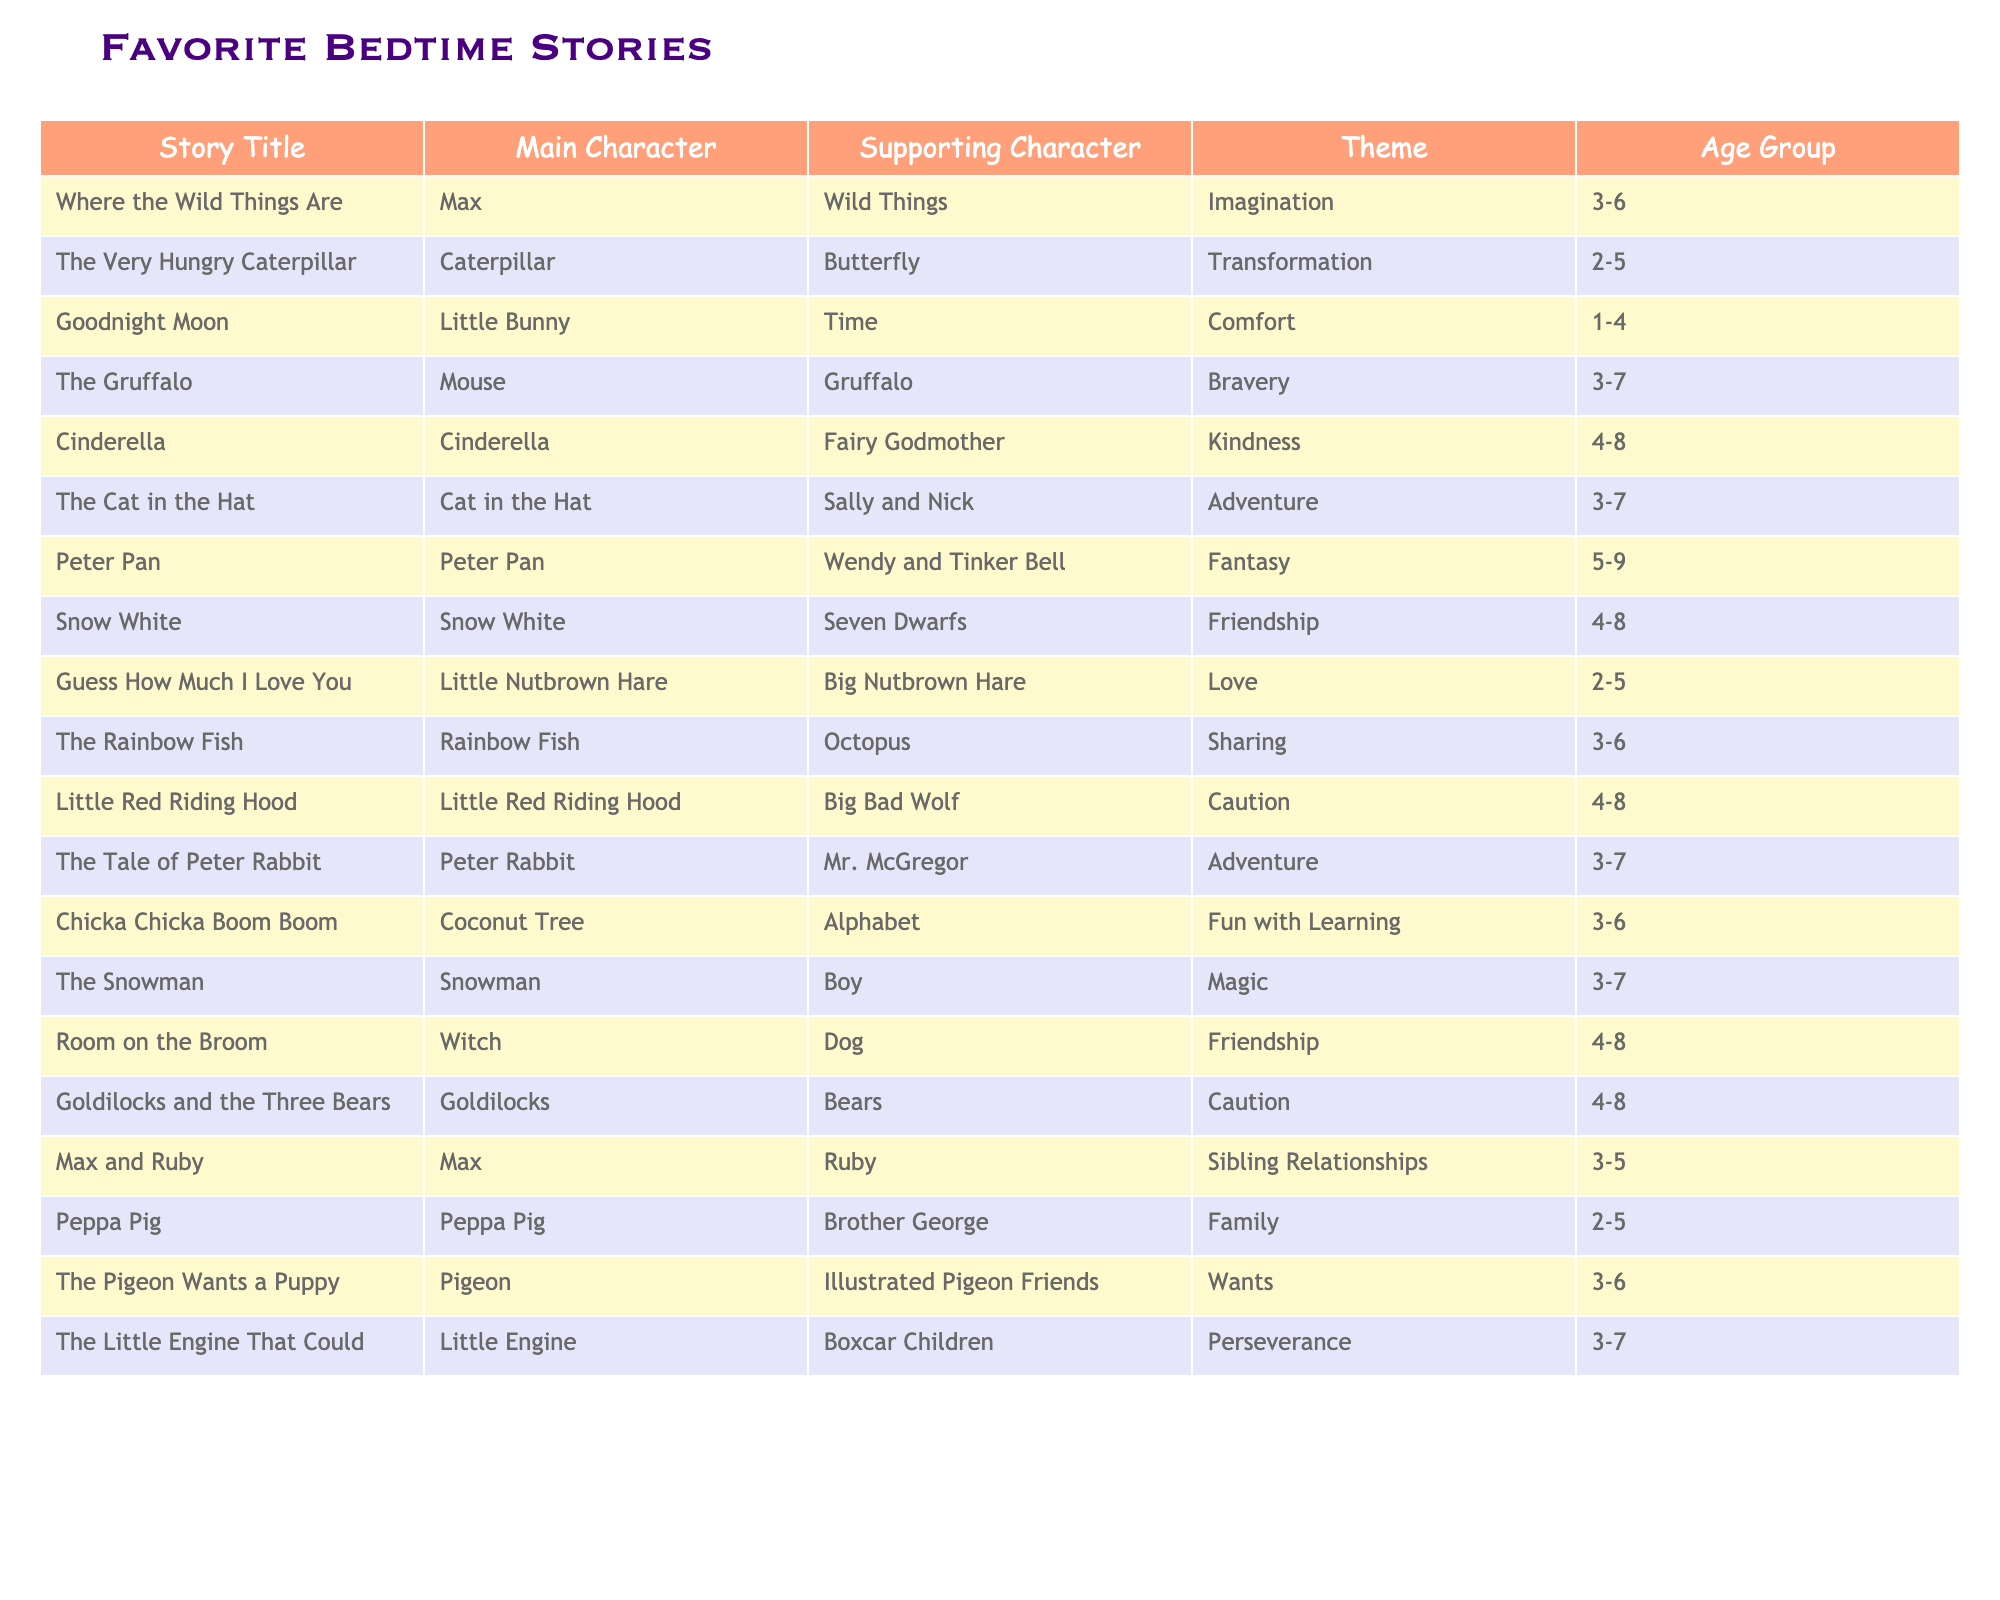What is the main character of "Cinderella"? The table states that the main character of "Cinderella" is Cinderella herself.
Answer: Cinderella Which story has the theme of imagination? According to the table, "Where the Wild Things Are" has the theme of imagination.
Answer: Where the Wild Things Are Is "The Pigeon Wants a Puppy" intended for age groups younger than 3? The age group for "The Pigeon Wants a Puppy" is listed as 3-6, which means it is not intended for age groups younger than 3.
Answer: No How many stories feature characters that emphasize caution? The table lists "Little Red Riding Hood," "Goldilocks and the Three Bears," and "Caution" as themes in these stories, totaling 2 stories that feature caution.
Answer: 2 Which story features the characters Peter Pan and Tinker Bell? "Peter Pan" features Peter Pan as the main character and Tinker Bell alongside Wendy as supporting characters.
Answer: Peter Pan What is the average age group range of the stories listed? The age groups are 1-4, 2-5, 3-6, 3-7, 4-8, and 5-9. Calculating the average involves finding the midpoint of each range and then averaging those values, resulting in an average of approximately 3.7.
Answer: 3.7 Which story has a theme of friendship and features an octopus as a supporting character? "The Rainbow Fish" has a theme of friendship and features an octopus as a supporting character according to the table.
Answer: The Rainbow Fish Are there more stories in the 3-6 age range than in the 4-8 age range? Upon counting the stories, there are 7 stories in the 3-6 age range and 5 stories in the 4-8 age range, meaning there are indeed more stories in the 3-6 range.
Answer: Yes Which story has the theme of love? The table indicates that "Guess How Much I Love You" has the theme of love.
Answer: Guess How Much I Love You What is the total number of unique main characters represented in the table? Upon reviewing the table, there are 17 unique main characters listed across the stories.
Answer: 17 